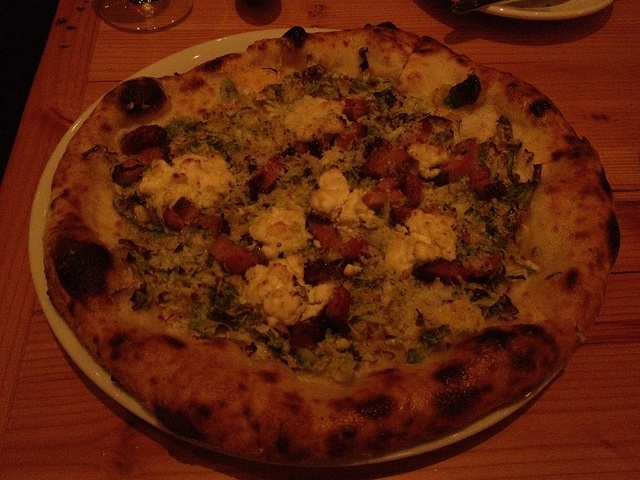Describe the objects in this image and their specific colors. I can see dining table in maroon, black, and brown tones, pizza in maroon, black, and brown tones, and cup in black, maroon, and brown tones in this image. 